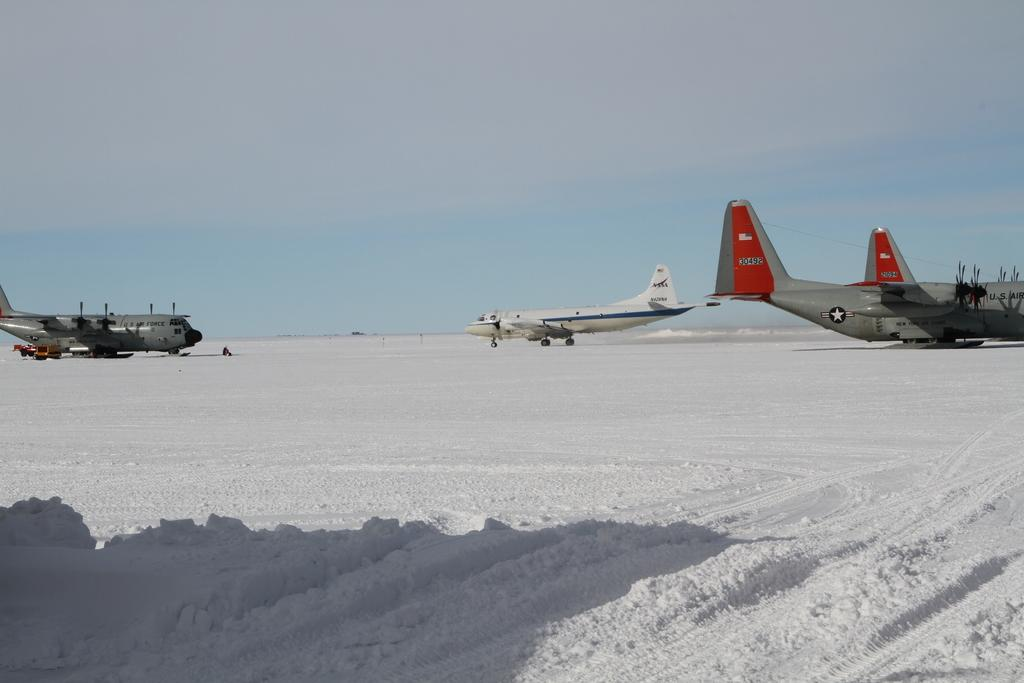What type of terrain is visible in the image? There is ground visible in the image, and it is covered in snow. What else can be seen on the ground in the image? There are aircrafts on the ground in the image. What colors are the aircrafts? The aircrafts are red, white, and grey in color. What can be seen in the background of the image? The sky is visible in the background of the image. Can you see a spade being used to clear the snow in the image? There is no spade visible in the image, and no one is using a spade to clear the snow. Is there a tin canister filled with ice in the image? There is no tin canister or ice present in the image. 